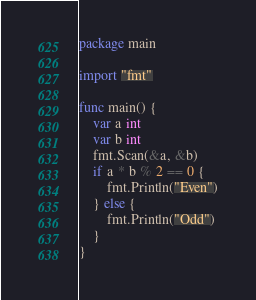Convert code to text. <code><loc_0><loc_0><loc_500><loc_500><_Go_>package main

import "fmt"

func main() {
	var a int
	var b int
	fmt.Scan(&a, &b)
	if a * b % 2 == 0 {
		fmt.Println("Even")
	} else {
		fmt.Println("Odd")
	}
}</code> 